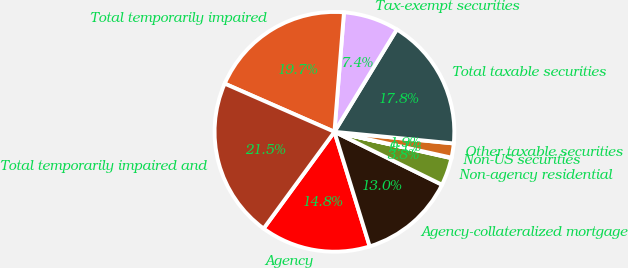Convert chart. <chart><loc_0><loc_0><loc_500><loc_500><pie_chart><fcel>Agency<fcel>Agency-collateralized mortgage<fcel>Non-agency residential<fcel>Non-US securities<fcel>Other taxable securities<fcel>Total taxable securities<fcel>Tax-exempt securities<fcel>Total temporarily impaired<fcel>Total temporarily impaired and<nl><fcel>14.81%<fcel>12.97%<fcel>3.75%<fcel>0.07%<fcel>1.91%<fcel>17.84%<fcel>7.44%<fcel>19.68%<fcel>21.53%<nl></chart> 